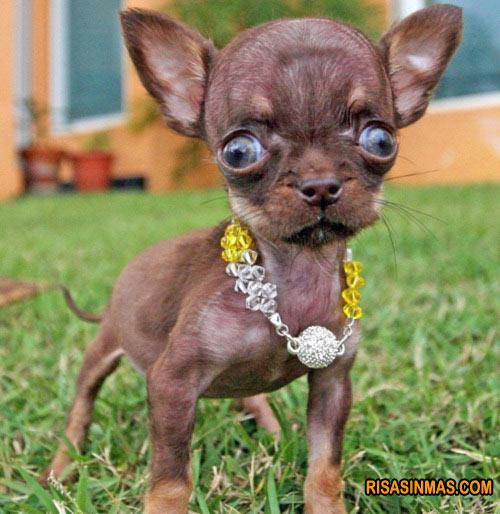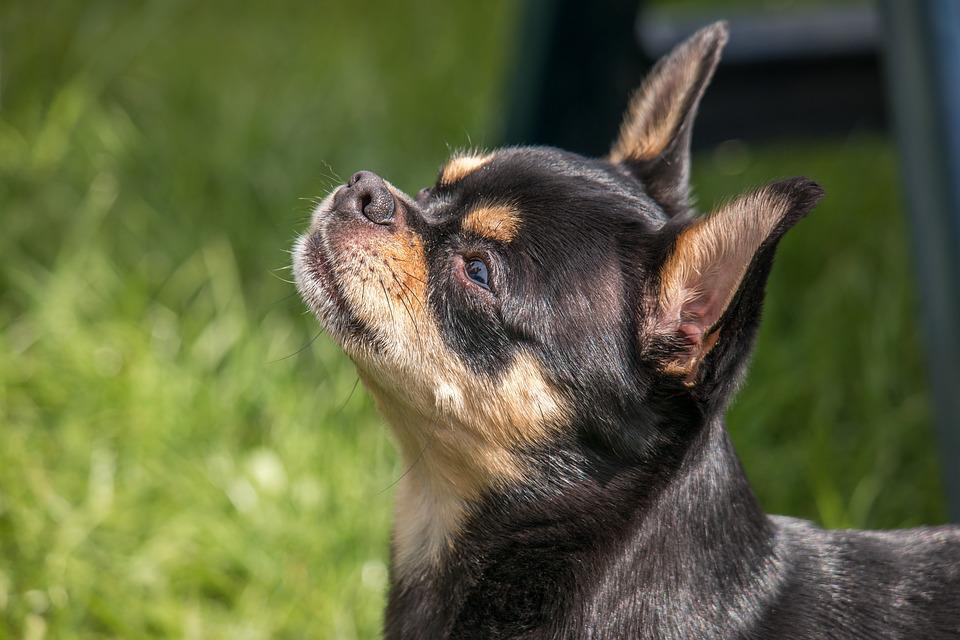The first image is the image on the left, the second image is the image on the right. For the images displayed, is the sentence "Both dogs are looking toward the camera." factually correct? Answer yes or no. No. 